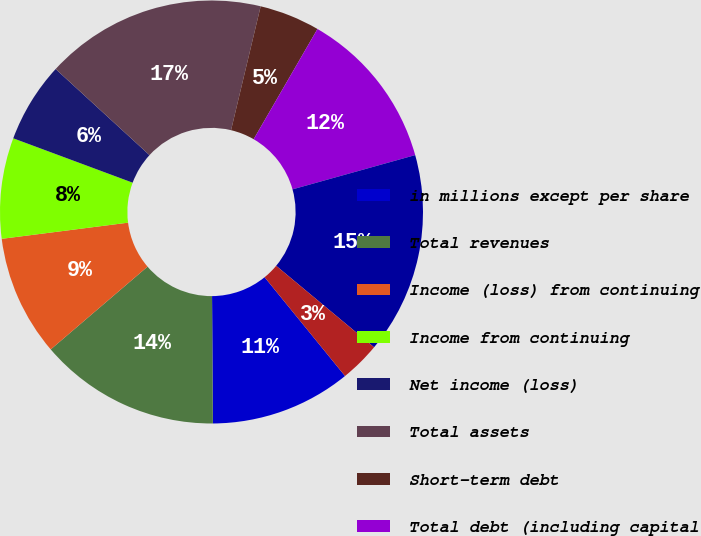<chart> <loc_0><loc_0><loc_500><loc_500><pie_chart><fcel>in millions except per share<fcel>Total revenues<fcel>Income (loss) from continuing<fcel>Income from continuing<fcel>Net income (loss)<fcel>Total assets<fcel>Short-term debt<fcel>Total debt (including capital<fcel>Total stockholders' equity<fcel>Basic<nl><fcel>10.77%<fcel>13.85%<fcel>9.23%<fcel>7.69%<fcel>6.15%<fcel>16.92%<fcel>4.62%<fcel>12.31%<fcel>15.38%<fcel>3.08%<nl></chart> 